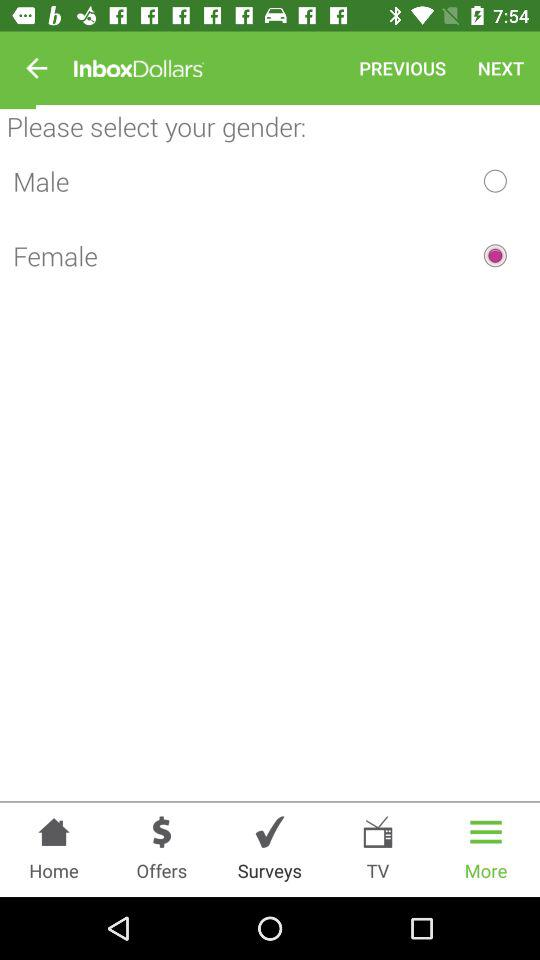What is the name of the application? The name of the application is "InboxDollars". 